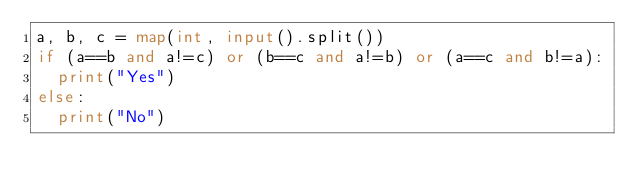Convert code to text. <code><loc_0><loc_0><loc_500><loc_500><_Python_>a, b, c = map(int, input().split())
if (a==b and a!=c) or (b==c and a!=b) or (a==c and b!=a):
  print("Yes")
else:
  print("No")</code> 